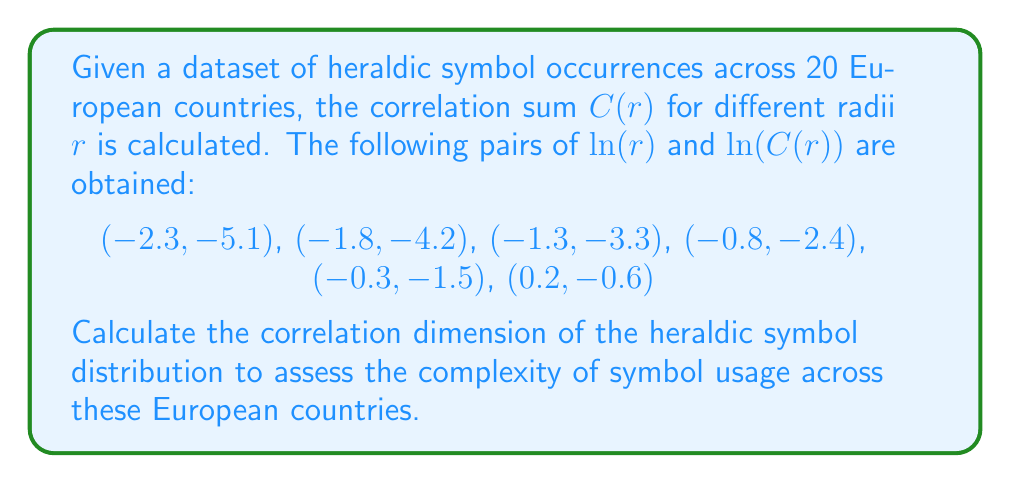Solve this math problem. To calculate the correlation dimension, we need to follow these steps:

1) The correlation dimension is defined as the slope of the line when plotting $\ln(C(r))$ against $\ln(r)$.

2) We can use the least squares method to find the best-fit line. The slope of this line will be our correlation dimension.

3) Let's denote $x = \ln(r)$ and $y = \ln(C(r))$. We need to calculate:

   $$m = \frac{n\sum xy - \sum x \sum y}{n\sum x^2 - (\sum x)^2}$$

   where $n$ is the number of data points (6 in this case).

4) Calculate the sums:
   $\sum x = -6.3$
   $\sum y = -17.1$
   $\sum xy = 26.13$
   $\sum x^2 = 11.63$

5) Plug these values into the formula:

   $$m = \frac{6(26.13) - (-6.3)(-17.1)}{6(11.63) - (-6.3)^2}$$

6) Simplify:

   $$m = \frac{156.78 - 107.73}{69.78 - 39.69} = \frac{49.05}{30.09} \approx 1.63$$

The correlation dimension is approximately 1.63.
Answer: 1.63 